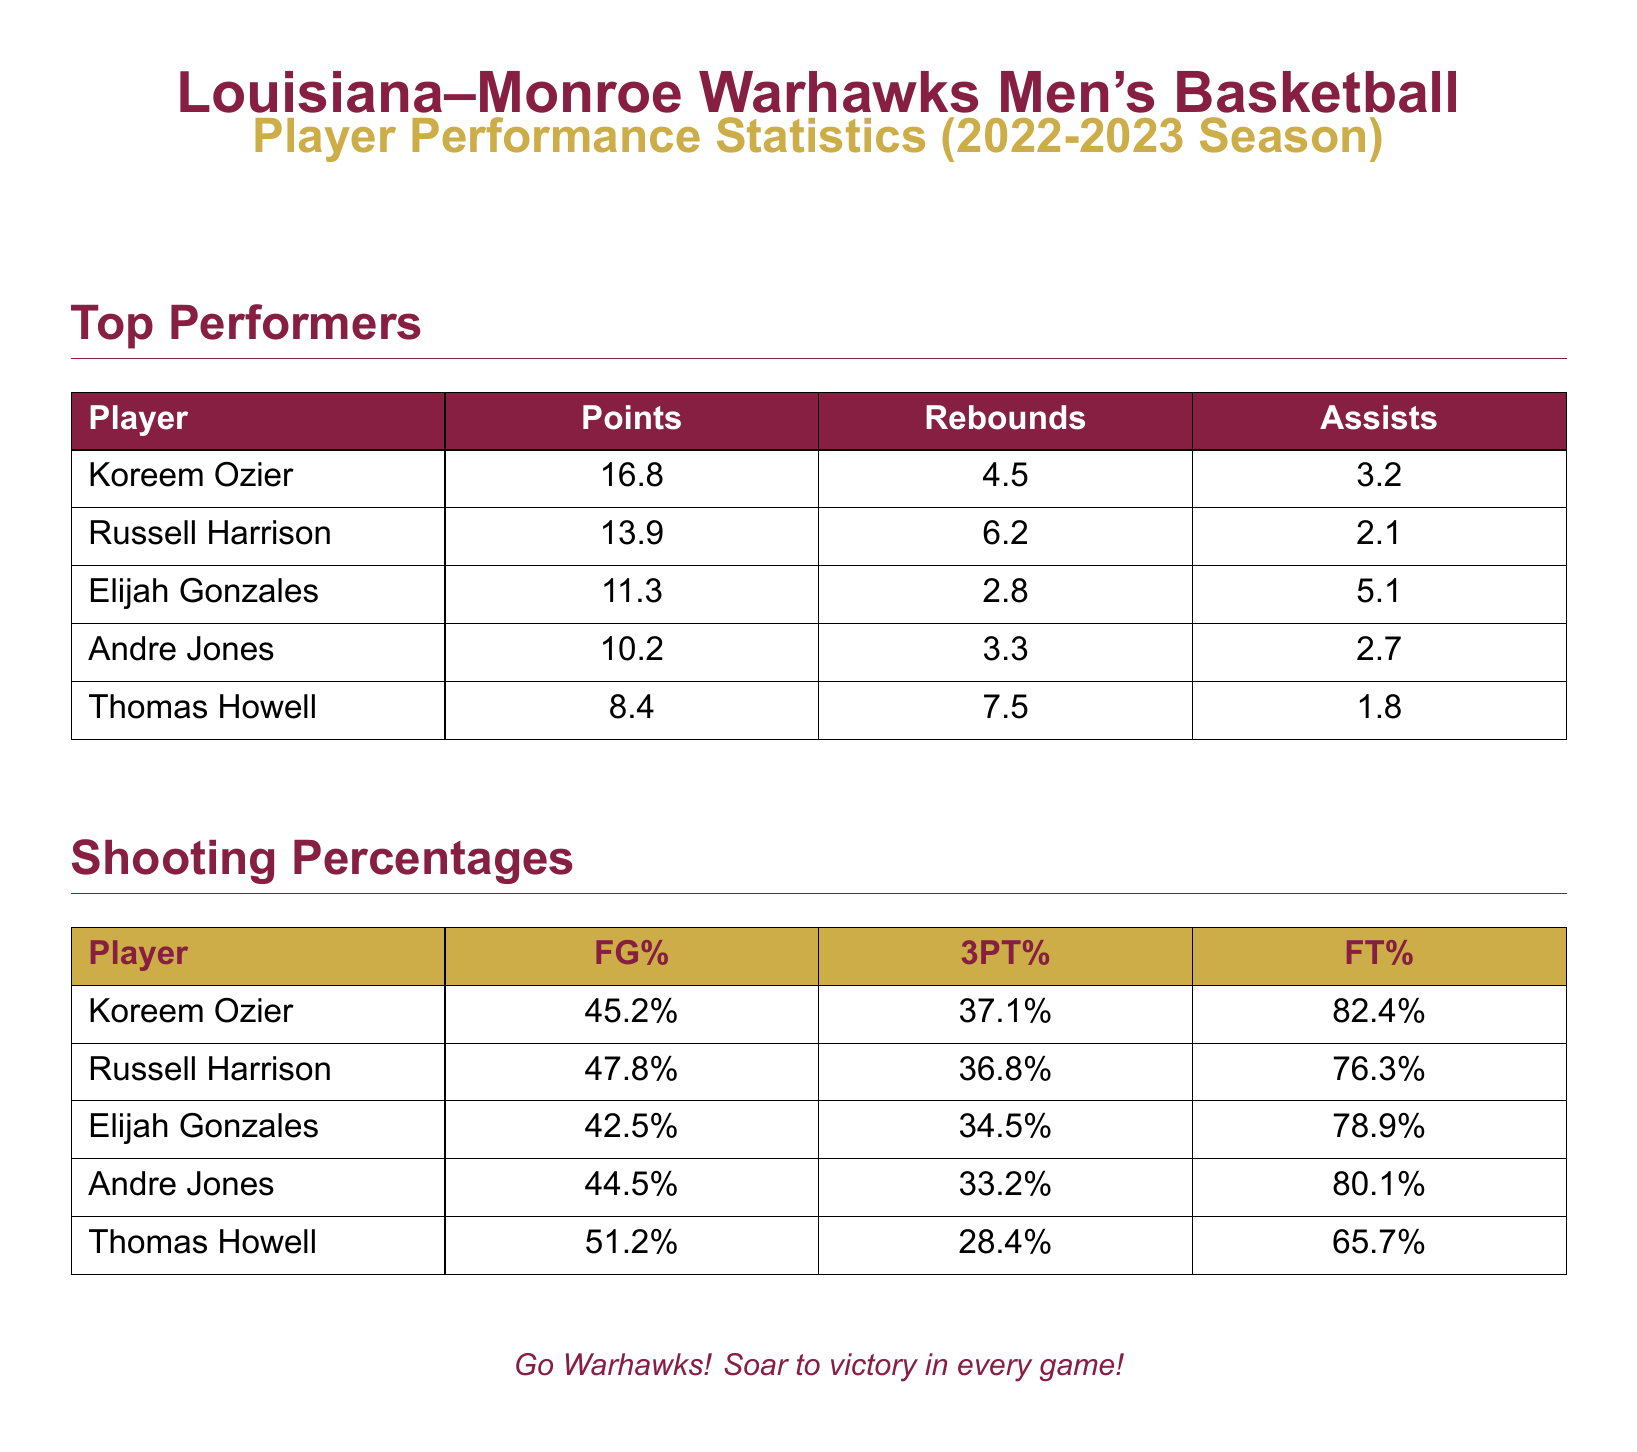What player scored the most points? The player with the highest points average is mentioned in the "Top Performers" section, which is Koreem Ozier with 16.8 points.
Answer: Koreem Ozier What was Russell Harrison's rebound average? The rebound average for Russell Harrison can be found in the "Top Performers" section, which lists it as 6.2 rebounds.
Answer: 6.2 What is Elijah Gonzales's assist average? Elijah Gonzales's assist average is specified in the "Top Performers" section as 5.1 assists.
Answer: 5.1 Who has the highest field goal percentage? The field goal percentage of each player is listed under "Shooting Percentages," with Thomas Howell having the highest at 51.2%.
Answer: Thomas Howell What was Andre Jones’s 3-point shooting percentage? Andre Jones's 3-point shooting percentage is shown in the "Shooting Percentages" section as 33.2%.
Answer: 33.2% Which player had the lowest free throw percentage? The free throw percentages are present in the "Shooting Percentages," and Thomas Howell has the lowest at 65.7%.
Answer: Thomas Howell How many players had an assist average of 3 or more? The "Top Performers" section lists players, allowing us to count; there are three players with 3 or more assists.
Answer: 3 What was the average points scored by the top performer? The average points for the highest scorer, mentioned in the "Top Performers" section, is specifically 16.8 points.
Answer: 16.8 Which player had the lowest points per game? The "Top Performers" section indicates that the player with the lowest scoring average is Thomas Howell at 8.4 points.
Answer: Thomas Howell 